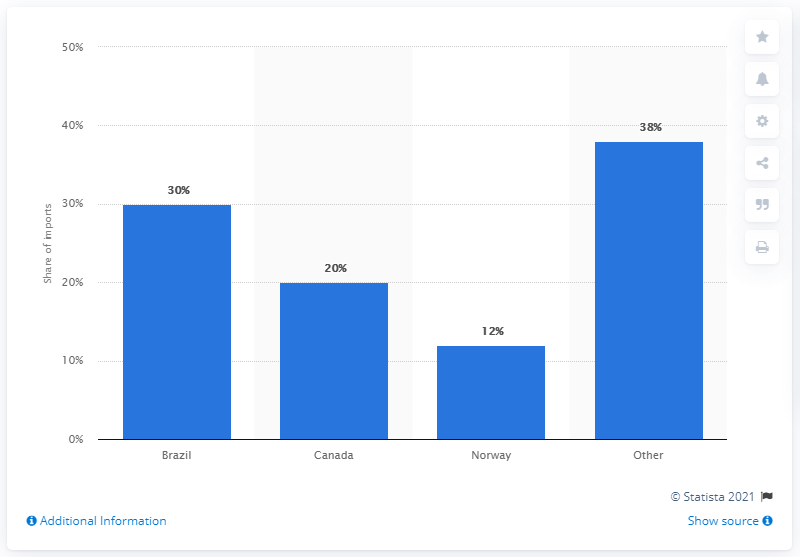Highlight a few significant elements in this photo. Brazil accounted for 30% of the United States' imports of silicon metal in the year reported. In 2019, Brazil accounted for approximately 30% of US silicon metal imports. 